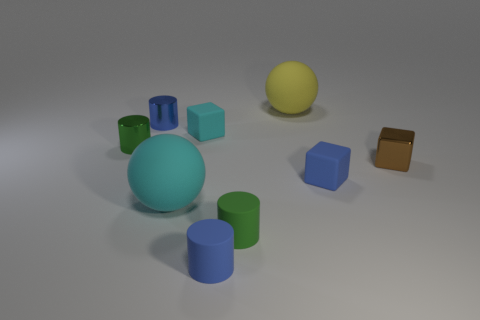Subtract 1 cylinders. How many cylinders are left? 3 Subtract all cyan balls. Subtract all cyan cylinders. How many balls are left? 1 Add 1 blue objects. How many objects exist? 10 Subtract all blocks. How many objects are left? 6 Add 4 tiny blue objects. How many tiny blue objects are left? 7 Add 3 large green objects. How many large green objects exist? 3 Subtract 0 yellow cylinders. How many objects are left? 9 Subtract all tiny blue metallic cylinders. Subtract all small green shiny objects. How many objects are left? 7 